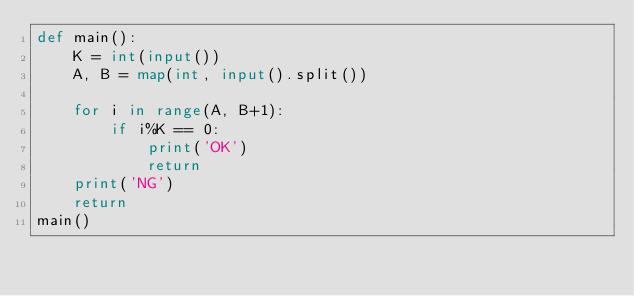Convert code to text. <code><loc_0><loc_0><loc_500><loc_500><_Python_>def main():
    K = int(input())
    A, B = map(int, input().split())

    for i in range(A, B+1):
        if i%K == 0:
            print('OK')
            return
    print('NG')
    return
main()</code> 